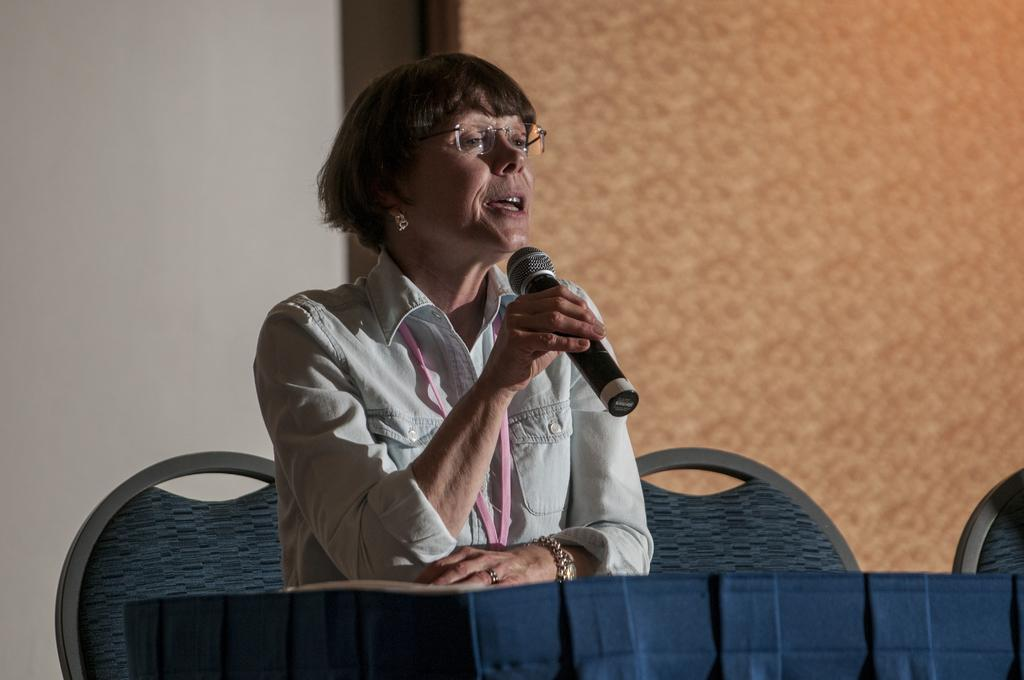What is the color of the wall in the image? The wall in the image is white. What is the woman in the image doing? The woman is sitting on a chair and talking on a mic. What is in front of the woman? There is a table in front of the woman. What type of land can be seen in the image? There is no land visible in the image; it features a woman sitting on a chair and talking on a mic in front of a white wall. Is there a chain attached to the mic in the image? There is no chain visible in the image; the woman is simply holding the mic while talking. 